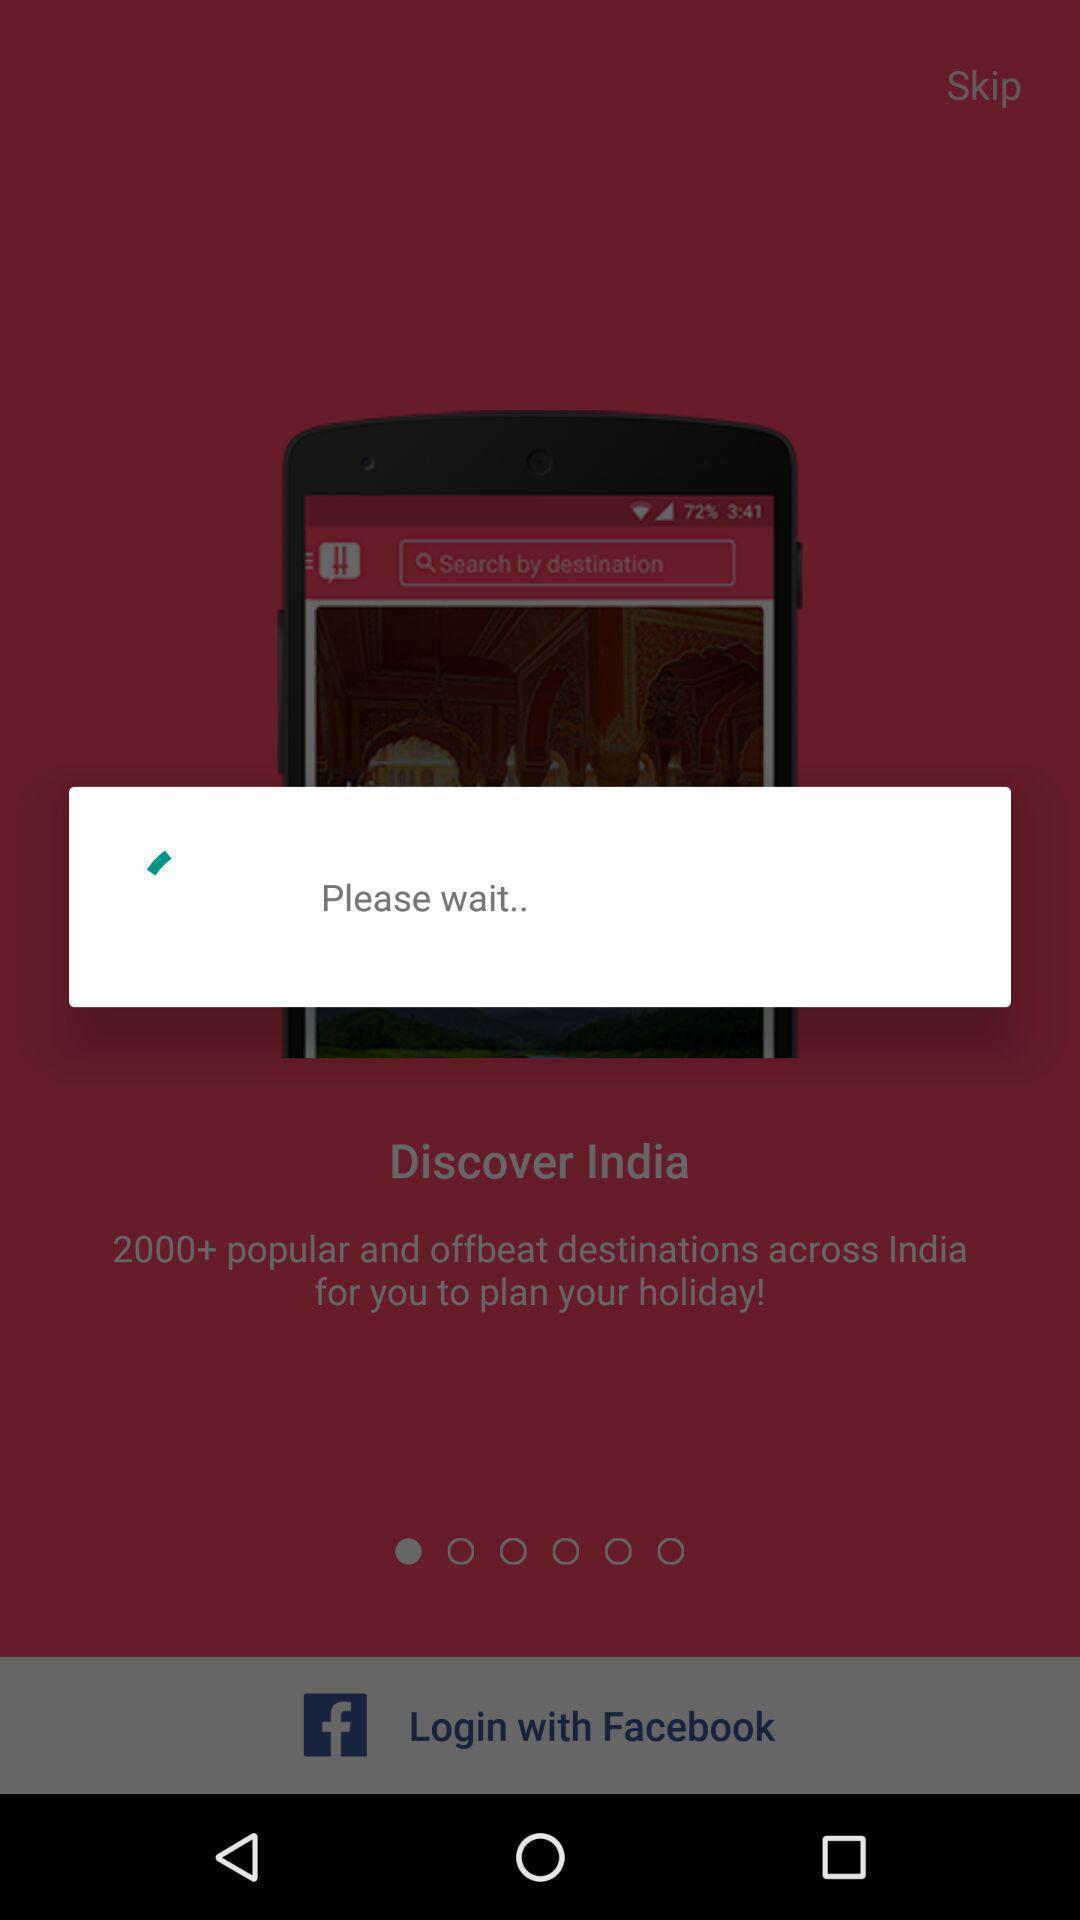Describe this image in words. Restoring the information of app. 